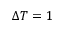<formula> <loc_0><loc_0><loc_500><loc_500>\Delta T = 1</formula> 